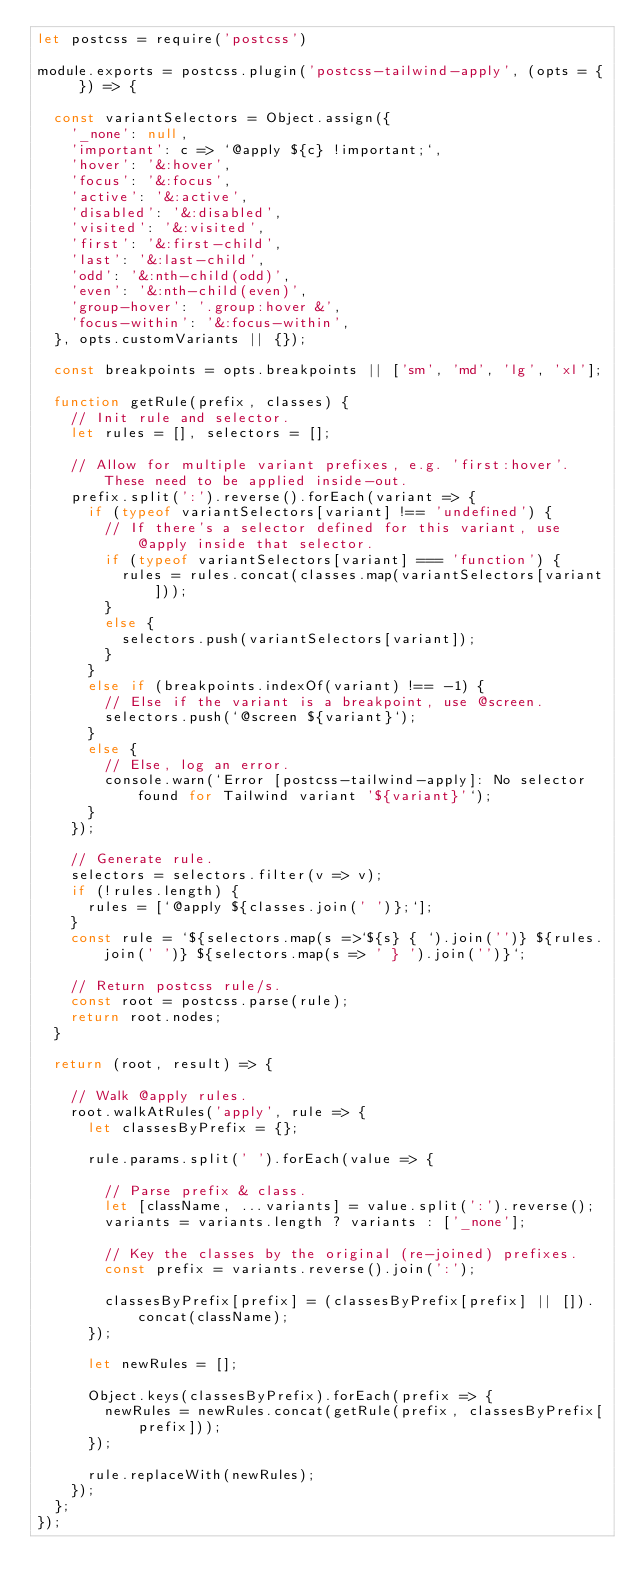<code> <loc_0><loc_0><loc_500><loc_500><_JavaScript_>let postcss = require('postcss')

module.exports = postcss.plugin('postcss-tailwind-apply', (opts = { }) => {

  const variantSelectors = Object.assign({
    '_none': null,
    'important': c => `@apply ${c} !important;`,
    'hover': '&:hover',
    'focus': '&:focus',
    'active': '&:active',
    'disabled': '&:disabled',
    'visited': '&:visited',
    'first': '&:first-child',
    'last': '&:last-child',
    'odd': '&:nth-child(odd)',
    'even': '&:nth-child(even)',
    'group-hover': '.group:hover &',
    'focus-within': '&:focus-within',
  }, opts.customVariants || {});

  const breakpoints = opts.breakpoints || ['sm', 'md', 'lg', 'xl'];

  function getRule(prefix, classes) {
    // Init rule and selector.
    let rules = [], selectors = [];

    // Allow for multiple variant prefixes, e.g. 'first:hover'. These need to be applied inside-out.
    prefix.split(':').reverse().forEach(variant => {
      if (typeof variantSelectors[variant] !== 'undefined') {
        // If there's a selector defined for this variant, use @apply inside that selector.
        if (typeof variantSelectors[variant] === 'function') {
          rules = rules.concat(classes.map(variantSelectors[variant]));
        }
        else {
          selectors.push(variantSelectors[variant]);
        }
      }
      else if (breakpoints.indexOf(variant) !== -1) {
        // Else if the variant is a breakpoint, use @screen.
        selectors.push(`@screen ${variant}`);
      }
      else {
        // Else, log an error.
        console.warn(`Error [postcss-tailwind-apply]: No selector found for Tailwind variant '${variant}'`);
      }
    });

    // Generate rule.
    selectors = selectors.filter(v => v);
    if (!rules.length) {
      rules = [`@apply ${classes.join(' ')};`];
    }
    const rule = `${selectors.map(s =>`${s} { `).join('')} ${rules.join(' ')} ${selectors.map(s => ' } ').join('')}`;

    // Return postcss rule/s.
    const root = postcss.parse(rule);
    return root.nodes;
  }

  return (root, result) => {

    // Walk @apply rules.
    root.walkAtRules('apply', rule => {
      let classesByPrefix = {};

      rule.params.split(' ').forEach(value => {

        // Parse prefix & class.
        let [className, ...variants] = value.split(':').reverse();
        variants = variants.length ? variants : ['_none'];

        // Key the classes by the original (re-joined) prefixes.
        const prefix = variants.reverse().join(':');

        classesByPrefix[prefix] = (classesByPrefix[prefix] || []).concat(className);
      });

      let newRules = [];

      Object.keys(classesByPrefix).forEach(prefix => {
        newRules = newRules.concat(getRule(prefix, classesByPrefix[prefix]));
      });

      rule.replaceWith(newRules);
    });
  };
});
</code> 